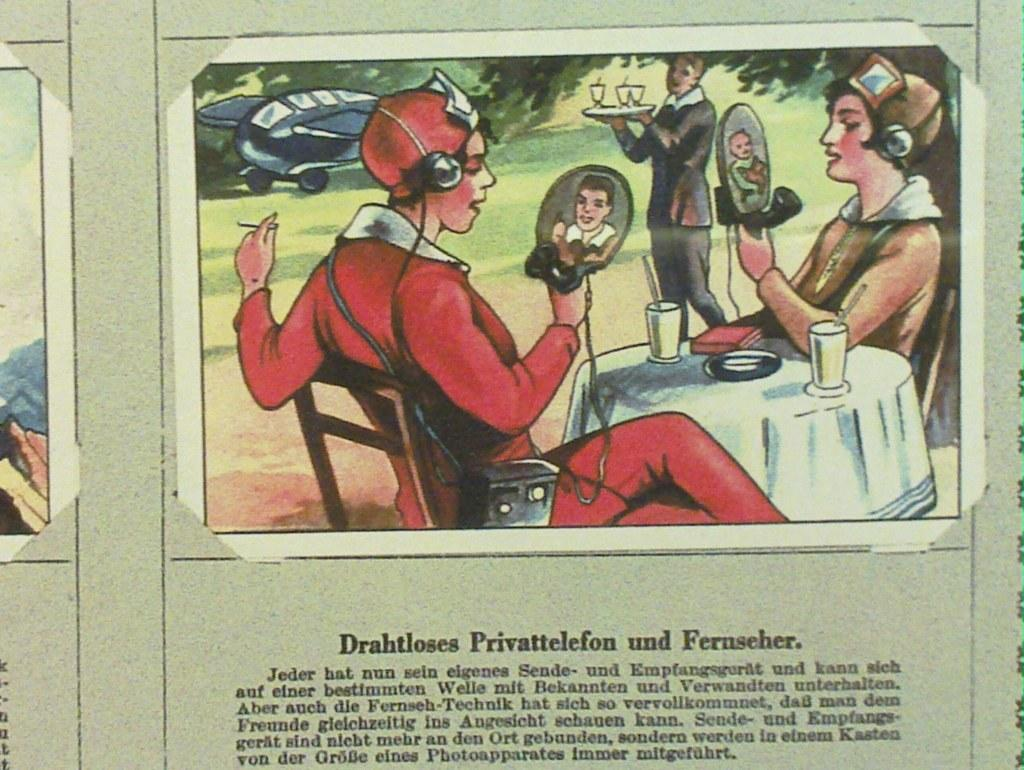What is the main subject of the image? The main subject of the image is a depiction poster. What can be seen on the poster in the image? There is text visible in the image. How much profit does the finger on the poster generate in the image? There is no finger present on the poster in the image, and therefore no such profit can be calculated. 